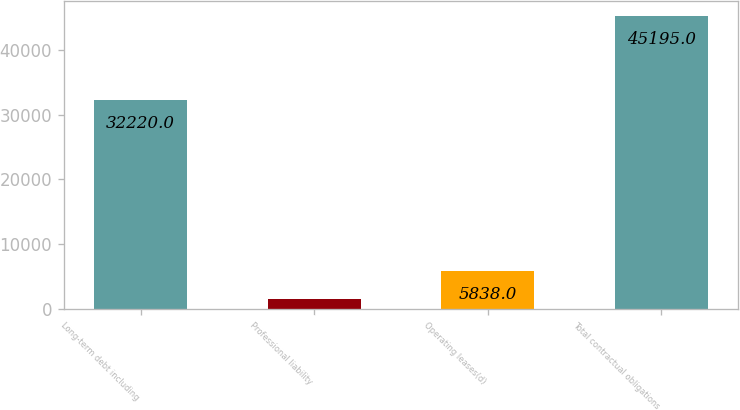Convert chart to OTSL. <chart><loc_0><loc_0><loc_500><loc_500><bar_chart><fcel>Long-term debt including<fcel>Professional liability<fcel>Operating leases(d)<fcel>Total contractual obligations<nl><fcel>32220<fcel>1465<fcel>5838<fcel>45195<nl></chart> 